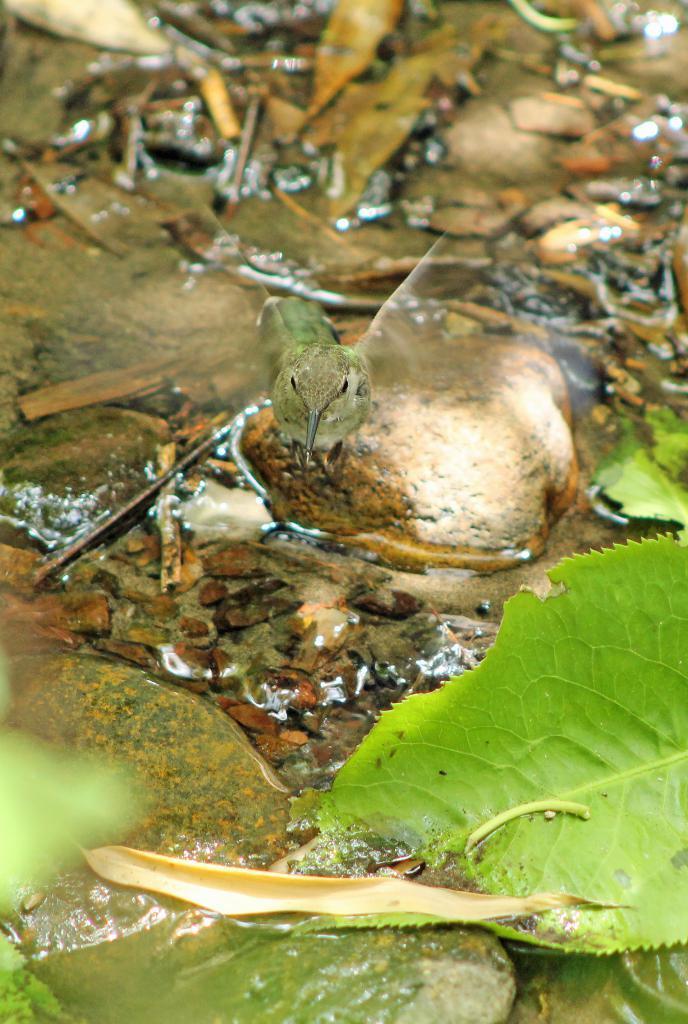Describe this image in one or two sentences. In this image we can see a bird on a stone. We can also see the water, stones and some leaves on the ground. 